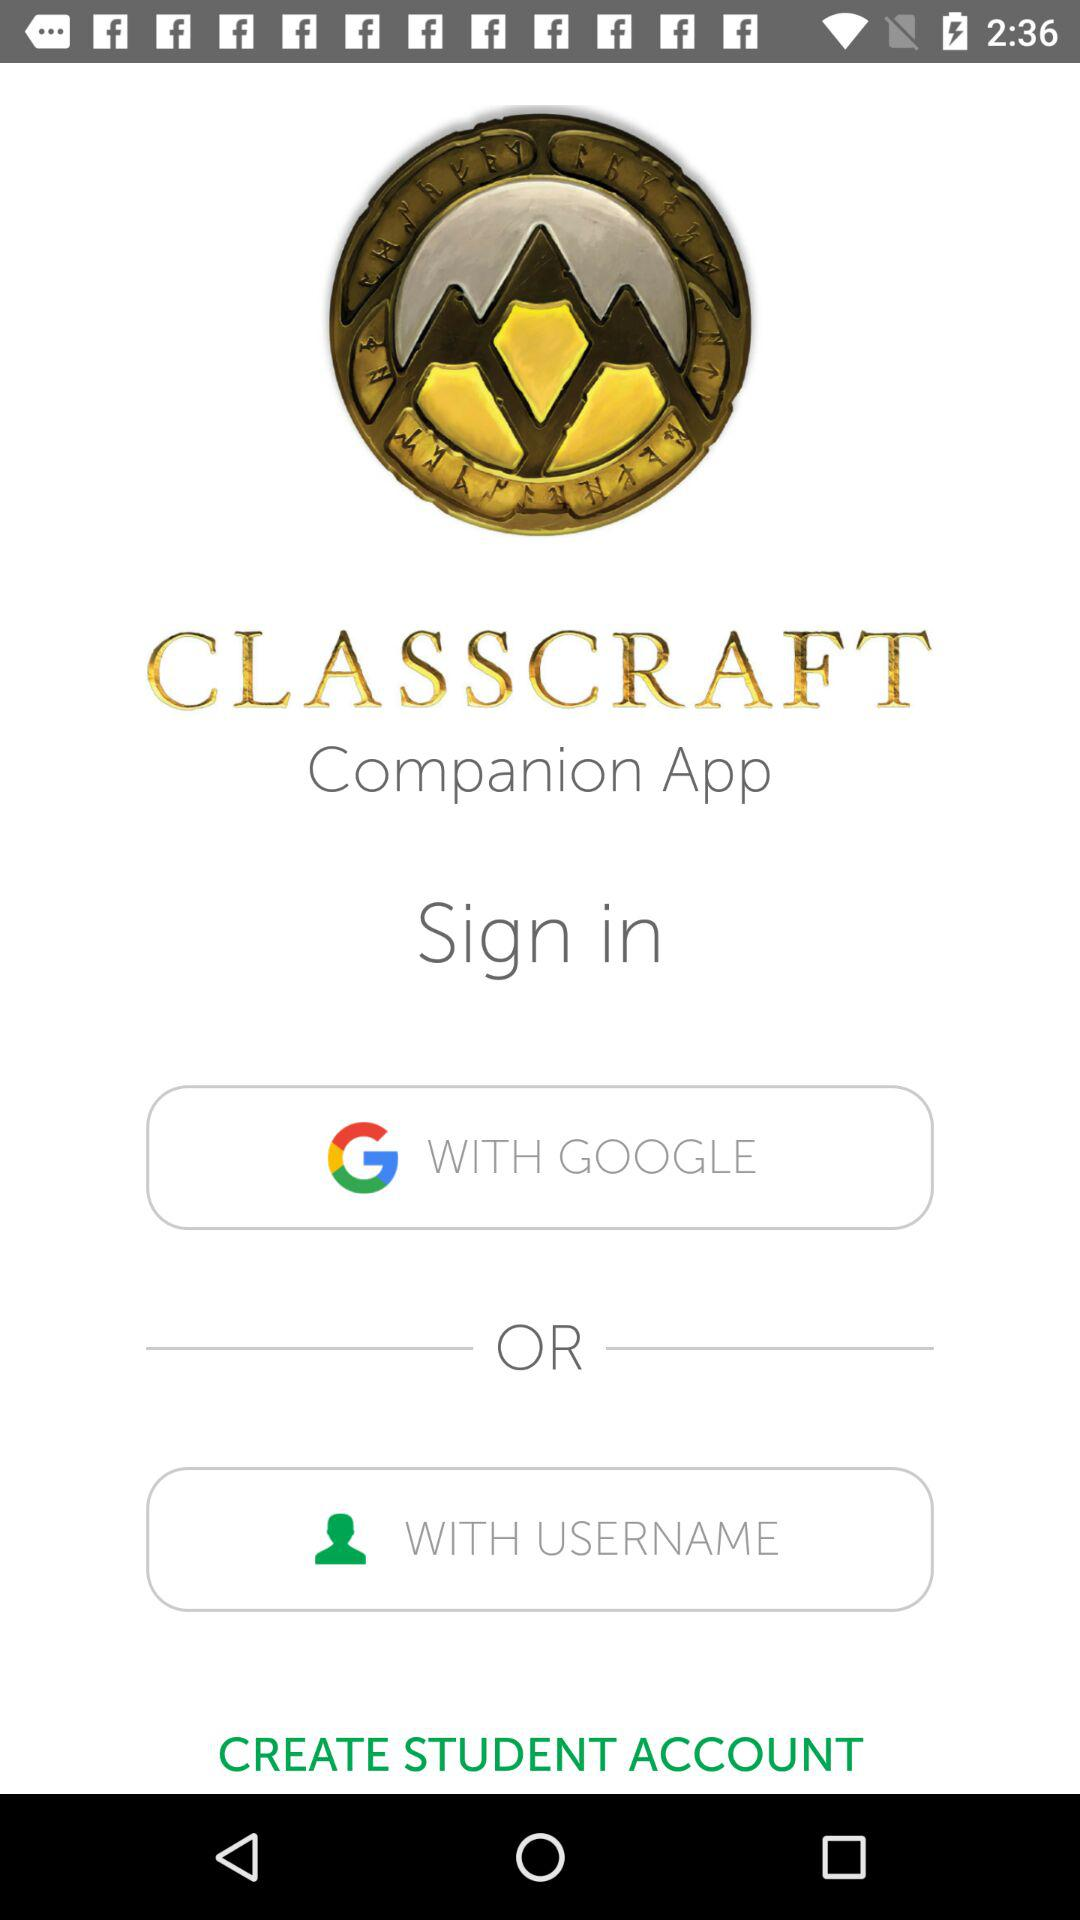What is the application name? The application name is "CLASSCRAFT". 